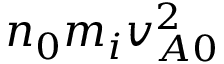Convert formula to latex. <formula><loc_0><loc_0><loc_500><loc_500>n _ { 0 } m _ { i } v _ { A 0 } ^ { 2 }</formula> 